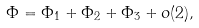Convert formula to latex. <formula><loc_0><loc_0><loc_500><loc_500>\Phi = \Phi _ { 1 } + \Phi _ { 2 } + \Phi _ { 3 } + o ( 2 ) ,</formula> 